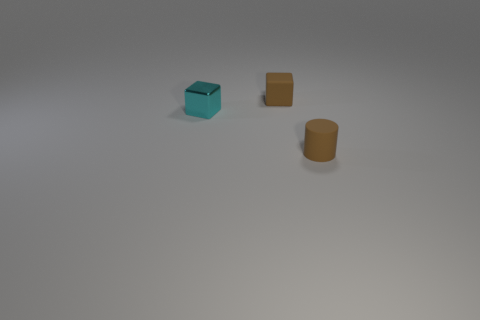There is a object that is to the right of the cyan object and in front of the brown block; what material is it? The object to the right of the cyan object and in front of the brown block appears to be made of a matte substance, likely plastic, considering its uniform color and lack of reflective qualities typically associated with metal or glass materials. 